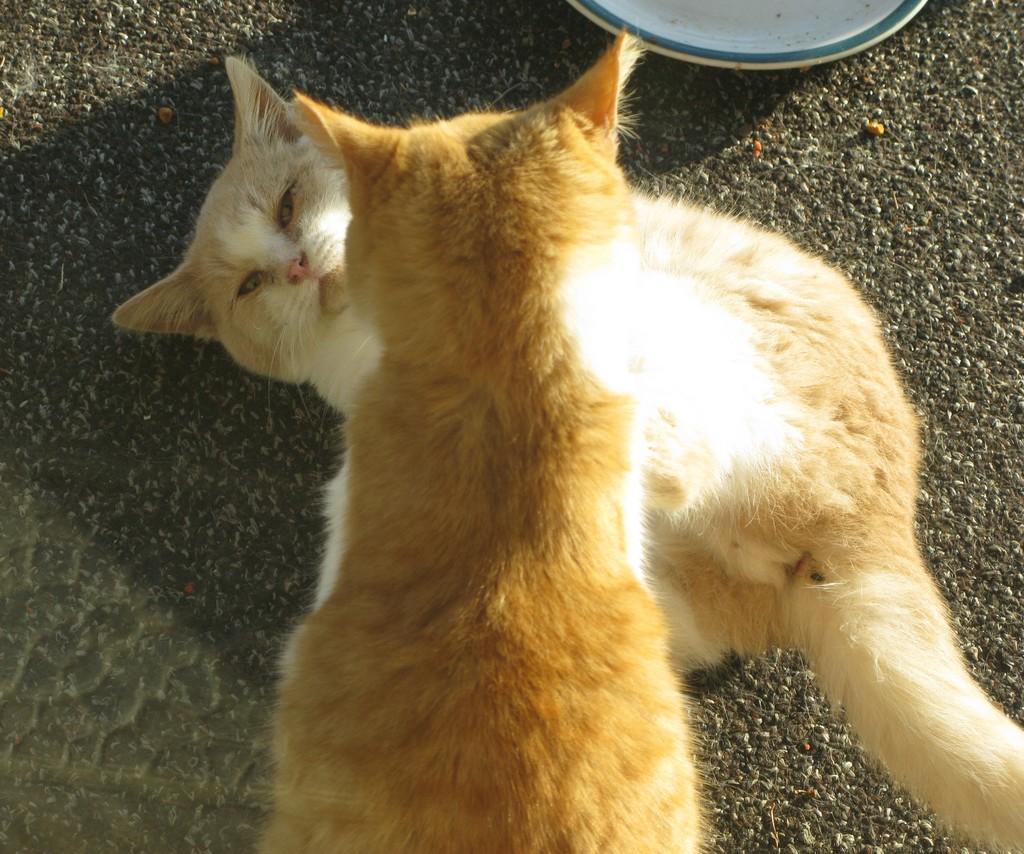How many cats are present in the image? There are two cats in the image. Where are the cats located? The cats are on the ground. Can you describe any other objects visible in the image? There is a plate visible in the background of the image. What type of apparel is the grandfather wearing in the image? There is no grandfather present in the image, so it is not possible to determine what type of apparel he might be wearing. 